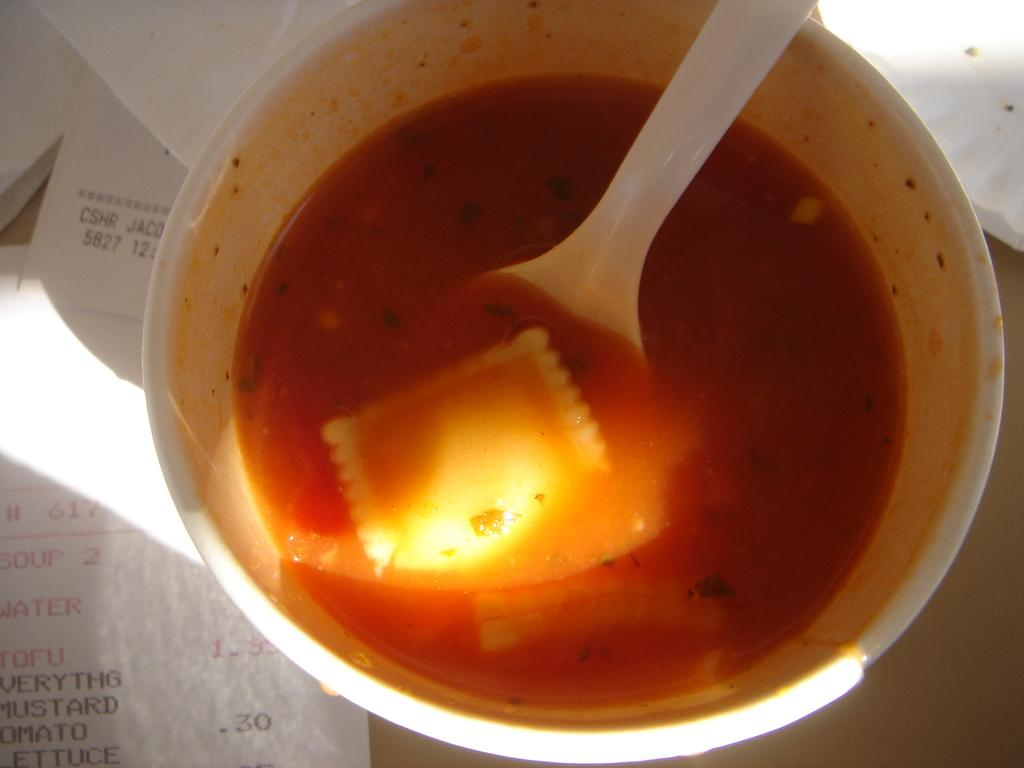What is in the bowl that is visible in the image? There is a bowl with food in the image. What utensil is used with the bowl? There is in the bowl. What else can be seen in the image besides the bowl and spoon? There is a paper in the image. What type of lock is on the bedroom door in the image? There is no bedroom or lock present in the image. 